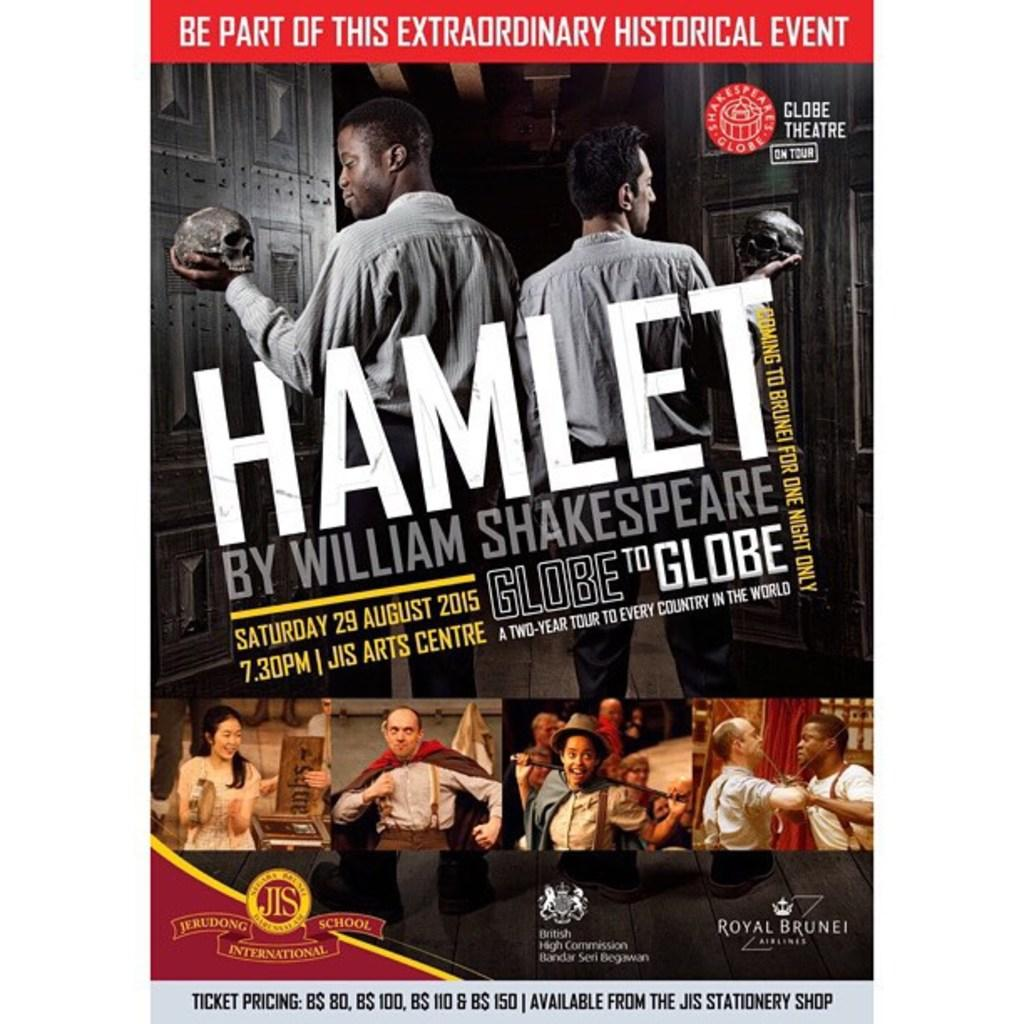<image>
Present a compact description of the photo's key features. A poster for a play at St James Art Centre: Hamlet by William Shakespeare. 